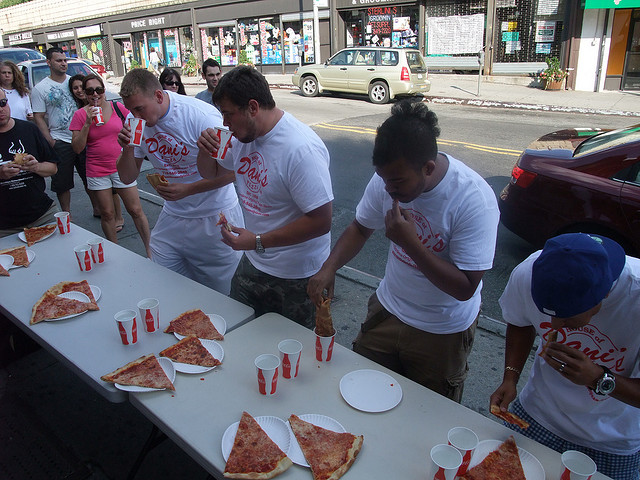Please transcribe the text information in this image. Dani's Dan's 